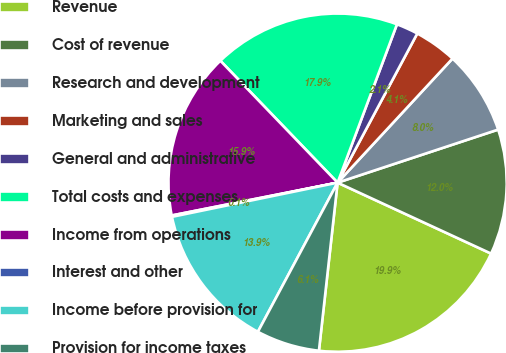<chart> <loc_0><loc_0><loc_500><loc_500><pie_chart><fcel>Revenue<fcel>Cost of revenue<fcel>Research and development<fcel>Marketing and sales<fcel>General and administrative<fcel>Total costs and expenses<fcel>Income from operations<fcel>Interest and other<fcel>Income before provision for<fcel>Provision for income taxes<nl><fcel>19.87%<fcel>11.97%<fcel>8.03%<fcel>4.08%<fcel>2.1%<fcel>17.9%<fcel>15.92%<fcel>0.13%<fcel>13.95%<fcel>6.05%<nl></chart> 